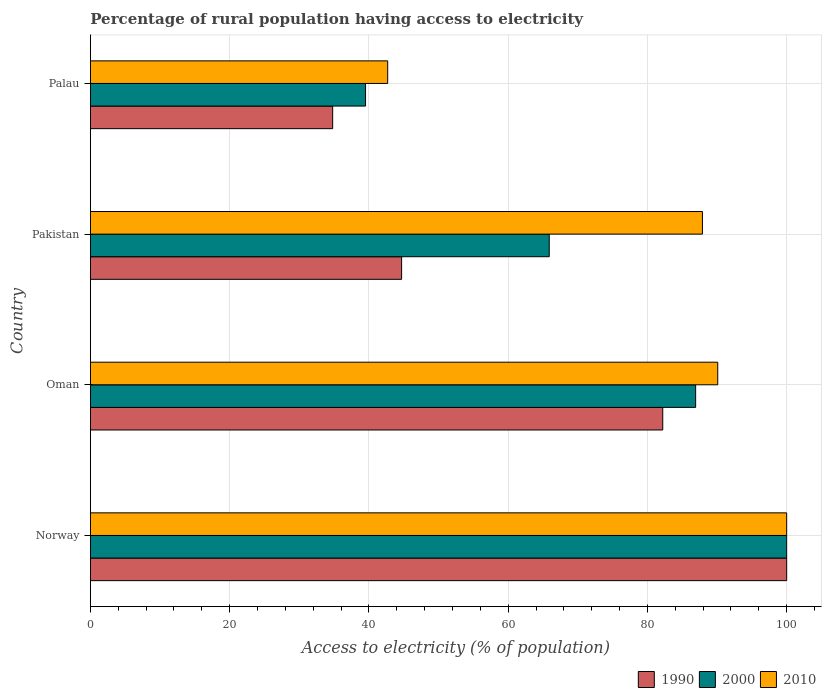Are the number of bars on each tick of the Y-axis equal?
Provide a short and direct response. Yes. How many bars are there on the 2nd tick from the bottom?
Provide a succinct answer. 3. What is the percentage of rural population having access to electricity in 2010 in Palau?
Keep it short and to the point. 42.7. Across all countries, what is the maximum percentage of rural population having access to electricity in 2010?
Offer a terse response. 100. Across all countries, what is the minimum percentage of rural population having access to electricity in 1990?
Offer a terse response. 34.8. In which country was the percentage of rural population having access to electricity in 2010 maximum?
Keep it short and to the point. Norway. In which country was the percentage of rural population having access to electricity in 2010 minimum?
Offer a very short reply. Palau. What is the total percentage of rural population having access to electricity in 2000 in the graph?
Your answer should be compact. 292.35. What is the difference between the percentage of rural population having access to electricity in 1990 in Oman and that in Pakistan?
Ensure brevity in your answer.  37.5. What is the difference between the percentage of rural population having access to electricity in 2000 in Palau and the percentage of rural population having access to electricity in 1990 in Oman?
Make the answer very short. -42.68. What is the average percentage of rural population having access to electricity in 1990 per country?
Offer a terse response. 65.43. What is the ratio of the percentage of rural population having access to electricity in 2010 in Pakistan to that in Palau?
Offer a terse response. 2.06. Is the percentage of rural population having access to electricity in 1990 in Pakistan less than that in Palau?
Offer a very short reply. No. What is the difference between the highest and the second highest percentage of rural population having access to electricity in 2010?
Ensure brevity in your answer.  9.9. What is the difference between the highest and the lowest percentage of rural population having access to electricity in 2010?
Offer a terse response. 57.3. In how many countries, is the percentage of rural population having access to electricity in 2000 greater than the average percentage of rural population having access to electricity in 2000 taken over all countries?
Keep it short and to the point. 2. What does the 1st bar from the top in Oman represents?
Your answer should be compact. 2010. Are all the bars in the graph horizontal?
Ensure brevity in your answer.  Yes. How many countries are there in the graph?
Ensure brevity in your answer.  4. Does the graph contain grids?
Your response must be concise. Yes. Where does the legend appear in the graph?
Give a very brief answer. Bottom right. How are the legend labels stacked?
Offer a very short reply. Horizontal. What is the title of the graph?
Your answer should be compact. Percentage of rural population having access to electricity. What is the label or title of the X-axis?
Provide a short and direct response. Access to electricity (% of population). What is the label or title of the Y-axis?
Your answer should be very brief. Country. What is the Access to electricity (% of population) in 1990 in Norway?
Your response must be concise. 100. What is the Access to electricity (% of population) in 2010 in Norway?
Ensure brevity in your answer.  100. What is the Access to electricity (% of population) in 1990 in Oman?
Your answer should be very brief. 82.2. What is the Access to electricity (% of population) of 2000 in Oman?
Your response must be concise. 86.93. What is the Access to electricity (% of population) in 2010 in Oman?
Offer a terse response. 90.1. What is the Access to electricity (% of population) of 1990 in Pakistan?
Give a very brief answer. 44.7. What is the Access to electricity (% of population) in 2000 in Pakistan?
Offer a terse response. 65.9. What is the Access to electricity (% of population) in 2010 in Pakistan?
Provide a succinct answer. 87.9. What is the Access to electricity (% of population) of 1990 in Palau?
Your answer should be very brief. 34.8. What is the Access to electricity (% of population) in 2000 in Palau?
Your answer should be compact. 39.52. What is the Access to electricity (% of population) in 2010 in Palau?
Provide a succinct answer. 42.7. Across all countries, what is the maximum Access to electricity (% of population) in 1990?
Offer a terse response. 100. Across all countries, what is the maximum Access to electricity (% of population) of 2000?
Provide a short and direct response. 100. Across all countries, what is the minimum Access to electricity (% of population) of 1990?
Provide a short and direct response. 34.8. Across all countries, what is the minimum Access to electricity (% of population) in 2000?
Give a very brief answer. 39.52. Across all countries, what is the minimum Access to electricity (% of population) in 2010?
Keep it short and to the point. 42.7. What is the total Access to electricity (% of population) in 1990 in the graph?
Offer a very short reply. 261.7. What is the total Access to electricity (% of population) of 2000 in the graph?
Your response must be concise. 292.35. What is the total Access to electricity (% of population) of 2010 in the graph?
Your response must be concise. 320.7. What is the difference between the Access to electricity (% of population) in 1990 in Norway and that in Oman?
Keep it short and to the point. 17.8. What is the difference between the Access to electricity (% of population) of 2000 in Norway and that in Oman?
Make the answer very short. 13.07. What is the difference between the Access to electricity (% of population) in 1990 in Norway and that in Pakistan?
Ensure brevity in your answer.  55.3. What is the difference between the Access to electricity (% of population) in 2000 in Norway and that in Pakistan?
Make the answer very short. 34.1. What is the difference between the Access to electricity (% of population) in 1990 in Norway and that in Palau?
Ensure brevity in your answer.  65.2. What is the difference between the Access to electricity (% of population) of 2000 in Norway and that in Palau?
Provide a succinct answer. 60.48. What is the difference between the Access to electricity (% of population) in 2010 in Norway and that in Palau?
Offer a terse response. 57.3. What is the difference between the Access to electricity (% of population) of 1990 in Oman and that in Pakistan?
Your answer should be very brief. 37.5. What is the difference between the Access to electricity (% of population) in 2000 in Oman and that in Pakistan?
Keep it short and to the point. 21.03. What is the difference between the Access to electricity (% of population) of 1990 in Oman and that in Palau?
Keep it short and to the point. 47.41. What is the difference between the Access to electricity (% of population) of 2000 in Oman and that in Palau?
Offer a terse response. 47.41. What is the difference between the Access to electricity (% of population) in 2010 in Oman and that in Palau?
Your response must be concise. 47.4. What is the difference between the Access to electricity (% of population) in 1990 in Pakistan and that in Palau?
Provide a short and direct response. 9.9. What is the difference between the Access to electricity (% of population) of 2000 in Pakistan and that in Palau?
Provide a short and direct response. 26.38. What is the difference between the Access to electricity (% of population) in 2010 in Pakistan and that in Palau?
Offer a very short reply. 45.2. What is the difference between the Access to electricity (% of population) in 1990 in Norway and the Access to electricity (% of population) in 2000 in Oman?
Keep it short and to the point. 13.07. What is the difference between the Access to electricity (% of population) in 1990 in Norway and the Access to electricity (% of population) in 2010 in Oman?
Offer a terse response. 9.9. What is the difference between the Access to electricity (% of population) of 1990 in Norway and the Access to electricity (% of population) of 2000 in Pakistan?
Ensure brevity in your answer.  34.1. What is the difference between the Access to electricity (% of population) of 1990 in Norway and the Access to electricity (% of population) of 2010 in Pakistan?
Your response must be concise. 12.1. What is the difference between the Access to electricity (% of population) in 2000 in Norway and the Access to electricity (% of population) in 2010 in Pakistan?
Make the answer very short. 12.1. What is the difference between the Access to electricity (% of population) in 1990 in Norway and the Access to electricity (% of population) in 2000 in Palau?
Give a very brief answer. 60.48. What is the difference between the Access to electricity (% of population) of 1990 in Norway and the Access to electricity (% of population) of 2010 in Palau?
Give a very brief answer. 57.3. What is the difference between the Access to electricity (% of population) of 2000 in Norway and the Access to electricity (% of population) of 2010 in Palau?
Provide a short and direct response. 57.3. What is the difference between the Access to electricity (% of population) of 1990 in Oman and the Access to electricity (% of population) of 2000 in Pakistan?
Offer a terse response. 16.3. What is the difference between the Access to electricity (% of population) in 1990 in Oman and the Access to electricity (% of population) in 2010 in Pakistan?
Give a very brief answer. -5.7. What is the difference between the Access to electricity (% of population) of 2000 in Oman and the Access to electricity (% of population) of 2010 in Pakistan?
Give a very brief answer. -0.97. What is the difference between the Access to electricity (% of population) of 1990 in Oman and the Access to electricity (% of population) of 2000 in Palau?
Provide a succinct answer. 42.68. What is the difference between the Access to electricity (% of population) in 1990 in Oman and the Access to electricity (% of population) in 2010 in Palau?
Your response must be concise. 39.5. What is the difference between the Access to electricity (% of population) in 2000 in Oman and the Access to electricity (% of population) in 2010 in Palau?
Offer a terse response. 44.23. What is the difference between the Access to electricity (% of population) of 1990 in Pakistan and the Access to electricity (% of population) of 2000 in Palau?
Keep it short and to the point. 5.18. What is the difference between the Access to electricity (% of population) in 1990 in Pakistan and the Access to electricity (% of population) in 2010 in Palau?
Offer a terse response. 2. What is the difference between the Access to electricity (% of population) of 2000 in Pakistan and the Access to electricity (% of population) of 2010 in Palau?
Give a very brief answer. 23.2. What is the average Access to electricity (% of population) in 1990 per country?
Offer a very short reply. 65.43. What is the average Access to electricity (% of population) in 2000 per country?
Provide a succinct answer. 73.09. What is the average Access to electricity (% of population) in 2010 per country?
Your answer should be very brief. 80.17. What is the difference between the Access to electricity (% of population) of 1990 and Access to electricity (% of population) of 2000 in Norway?
Your response must be concise. 0. What is the difference between the Access to electricity (% of population) of 1990 and Access to electricity (% of population) of 2010 in Norway?
Provide a short and direct response. 0. What is the difference between the Access to electricity (% of population) in 1990 and Access to electricity (% of population) in 2000 in Oman?
Your answer should be very brief. -4.72. What is the difference between the Access to electricity (% of population) of 1990 and Access to electricity (% of population) of 2010 in Oman?
Make the answer very short. -7.9. What is the difference between the Access to electricity (% of population) in 2000 and Access to electricity (% of population) in 2010 in Oman?
Provide a succinct answer. -3.17. What is the difference between the Access to electricity (% of population) in 1990 and Access to electricity (% of population) in 2000 in Pakistan?
Your response must be concise. -21.2. What is the difference between the Access to electricity (% of population) in 1990 and Access to electricity (% of population) in 2010 in Pakistan?
Provide a succinct answer. -43.2. What is the difference between the Access to electricity (% of population) in 2000 and Access to electricity (% of population) in 2010 in Pakistan?
Offer a terse response. -22. What is the difference between the Access to electricity (% of population) in 1990 and Access to electricity (% of population) in 2000 in Palau?
Make the answer very short. -4.72. What is the difference between the Access to electricity (% of population) of 1990 and Access to electricity (% of population) of 2010 in Palau?
Keep it short and to the point. -7.9. What is the difference between the Access to electricity (% of population) in 2000 and Access to electricity (% of population) in 2010 in Palau?
Offer a terse response. -3.18. What is the ratio of the Access to electricity (% of population) in 1990 in Norway to that in Oman?
Keep it short and to the point. 1.22. What is the ratio of the Access to electricity (% of population) in 2000 in Norway to that in Oman?
Your answer should be very brief. 1.15. What is the ratio of the Access to electricity (% of population) in 2010 in Norway to that in Oman?
Offer a very short reply. 1.11. What is the ratio of the Access to electricity (% of population) of 1990 in Norway to that in Pakistan?
Provide a succinct answer. 2.24. What is the ratio of the Access to electricity (% of population) in 2000 in Norway to that in Pakistan?
Ensure brevity in your answer.  1.52. What is the ratio of the Access to electricity (% of population) of 2010 in Norway to that in Pakistan?
Make the answer very short. 1.14. What is the ratio of the Access to electricity (% of population) in 1990 in Norway to that in Palau?
Provide a succinct answer. 2.87. What is the ratio of the Access to electricity (% of population) in 2000 in Norway to that in Palau?
Ensure brevity in your answer.  2.53. What is the ratio of the Access to electricity (% of population) of 2010 in Norway to that in Palau?
Ensure brevity in your answer.  2.34. What is the ratio of the Access to electricity (% of population) of 1990 in Oman to that in Pakistan?
Offer a terse response. 1.84. What is the ratio of the Access to electricity (% of population) of 2000 in Oman to that in Pakistan?
Make the answer very short. 1.32. What is the ratio of the Access to electricity (% of population) in 2010 in Oman to that in Pakistan?
Ensure brevity in your answer.  1.02. What is the ratio of the Access to electricity (% of population) in 1990 in Oman to that in Palau?
Provide a short and direct response. 2.36. What is the ratio of the Access to electricity (% of population) in 2000 in Oman to that in Palau?
Your response must be concise. 2.2. What is the ratio of the Access to electricity (% of population) of 2010 in Oman to that in Palau?
Offer a terse response. 2.11. What is the ratio of the Access to electricity (% of population) of 1990 in Pakistan to that in Palau?
Ensure brevity in your answer.  1.28. What is the ratio of the Access to electricity (% of population) of 2000 in Pakistan to that in Palau?
Offer a terse response. 1.67. What is the ratio of the Access to electricity (% of population) of 2010 in Pakistan to that in Palau?
Your answer should be compact. 2.06. What is the difference between the highest and the second highest Access to electricity (% of population) of 1990?
Your answer should be very brief. 17.8. What is the difference between the highest and the second highest Access to electricity (% of population) in 2000?
Offer a terse response. 13.07. What is the difference between the highest and the second highest Access to electricity (% of population) in 2010?
Keep it short and to the point. 9.9. What is the difference between the highest and the lowest Access to electricity (% of population) of 1990?
Ensure brevity in your answer.  65.2. What is the difference between the highest and the lowest Access to electricity (% of population) in 2000?
Provide a succinct answer. 60.48. What is the difference between the highest and the lowest Access to electricity (% of population) of 2010?
Provide a short and direct response. 57.3. 